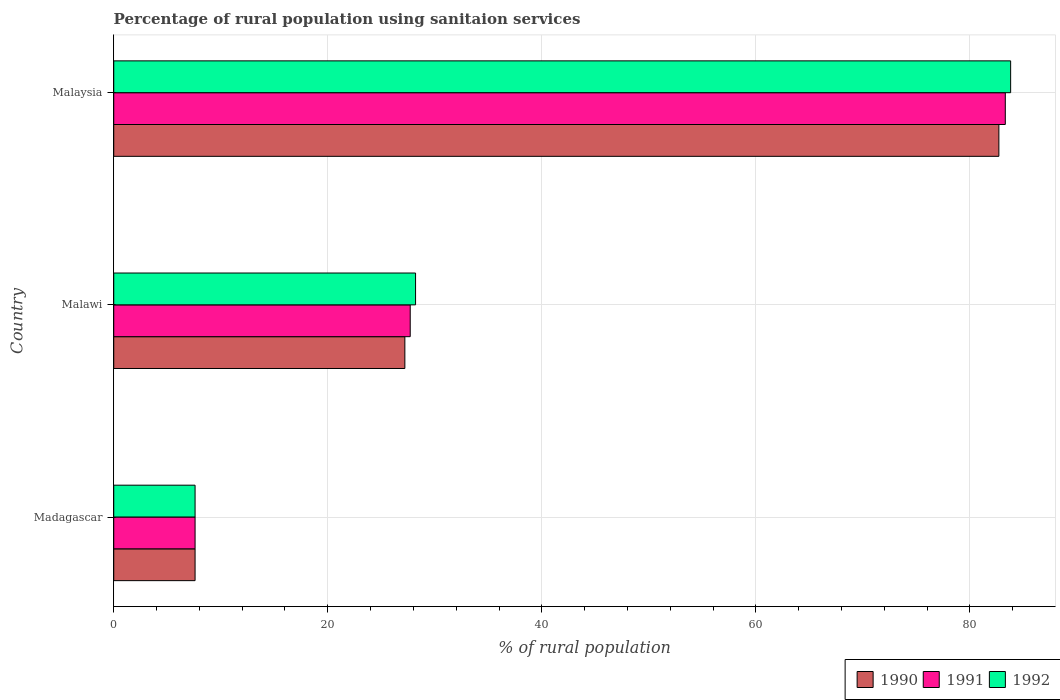How many different coloured bars are there?
Offer a terse response. 3. What is the label of the 2nd group of bars from the top?
Give a very brief answer. Malawi. Across all countries, what is the maximum percentage of rural population using sanitaion services in 1991?
Ensure brevity in your answer.  83.3. In which country was the percentage of rural population using sanitaion services in 1990 maximum?
Make the answer very short. Malaysia. In which country was the percentage of rural population using sanitaion services in 1991 minimum?
Provide a succinct answer. Madagascar. What is the total percentage of rural population using sanitaion services in 1992 in the graph?
Keep it short and to the point. 119.6. What is the difference between the percentage of rural population using sanitaion services in 1991 in Madagascar and that in Malawi?
Offer a terse response. -20.1. What is the difference between the percentage of rural population using sanitaion services in 1992 in Malawi and the percentage of rural population using sanitaion services in 1990 in Malaysia?
Your answer should be compact. -54.5. What is the average percentage of rural population using sanitaion services in 1991 per country?
Offer a terse response. 39.53. What is the difference between the percentage of rural population using sanitaion services in 1990 and percentage of rural population using sanitaion services in 1992 in Malaysia?
Offer a very short reply. -1.1. In how many countries, is the percentage of rural population using sanitaion services in 1991 greater than 16 %?
Provide a succinct answer. 2. What is the ratio of the percentage of rural population using sanitaion services in 1991 in Malawi to that in Malaysia?
Your response must be concise. 0.33. What is the difference between the highest and the second highest percentage of rural population using sanitaion services in 1991?
Provide a short and direct response. 55.6. What is the difference between the highest and the lowest percentage of rural population using sanitaion services in 1990?
Offer a very short reply. 75.1. Is the sum of the percentage of rural population using sanitaion services in 1992 in Madagascar and Malawi greater than the maximum percentage of rural population using sanitaion services in 1991 across all countries?
Give a very brief answer. No. Are all the bars in the graph horizontal?
Provide a succinct answer. Yes. Does the graph contain any zero values?
Your answer should be very brief. No. Does the graph contain grids?
Give a very brief answer. Yes. Where does the legend appear in the graph?
Keep it short and to the point. Bottom right. What is the title of the graph?
Make the answer very short. Percentage of rural population using sanitaion services. What is the label or title of the X-axis?
Provide a succinct answer. % of rural population. What is the % of rural population in 1992 in Madagascar?
Your answer should be very brief. 7.6. What is the % of rural population of 1990 in Malawi?
Offer a very short reply. 27.2. What is the % of rural population of 1991 in Malawi?
Provide a short and direct response. 27.7. What is the % of rural population of 1992 in Malawi?
Ensure brevity in your answer.  28.2. What is the % of rural population of 1990 in Malaysia?
Offer a very short reply. 82.7. What is the % of rural population in 1991 in Malaysia?
Offer a terse response. 83.3. What is the % of rural population of 1992 in Malaysia?
Give a very brief answer. 83.8. Across all countries, what is the maximum % of rural population of 1990?
Provide a succinct answer. 82.7. Across all countries, what is the maximum % of rural population in 1991?
Make the answer very short. 83.3. Across all countries, what is the maximum % of rural population of 1992?
Offer a terse response. 83.8. What is the total % of rural population in 1990 in the graph?
Make the answer very short. 117.5. What is the total % of rural population in 1991 in the graph?
Keep it short and to the point. 118.6. What is the total % of rural population of 1992 in the graph?
Give a very brief answer. 119.6. What is the difference between the % of rural population of 1990 in Madagascar and that in Malawi?
Give a very brief answer. -19.6. What is the difference between the % of rural population in 1991 in Madagascar and that in Malawi?
Your answer should be very brief. -20.1. What is the difference between the % of rural population of 1992 in Madagascar and that in Malawi?
Your response must be concise. -20.6. What is the difference between the % of rural population of 1990 in Madagascar and that in Malaysia?
Give a very brief answer. -75.1. What is the difference between the % of rural population of 1991 in Madagascar and that in Malaysia?
Your response must be concise. -75.7. What is the difference between the % of rural population in 1992 in Madagascar and that in Malaysia?
Make the answer very short. -76.2. What is the difference between the % of rural population in 1990 in Malawi and that in Malaysia?
Provide a short and direct response. -55.5. What is the difference between the % of rural population of 1991 in Malawi and that in Malaysia?
Your response must be concise. -55.6. What is the difference between the % of rural population in 1992 in Malawi and that in Malaysia?
Your answer should be compact. -55.6. What is the difference between the % of rural population in 1990 in Madagascar and the % of rural population in 1991 in Malawi?
Provide a short and direct response. -20.1. What is the difference between the % of rural population in 1990 in Madagascar and the % of rural population in 1992 in Malawi?
Give a very brief answer. -20.6. What is the difference between the % of rural population of 1991 in Madagascar and the % of rural population of 1992 in Malawi?
Offer a terse response. -20.6. What is the difference between the % of rural population of 1990 in Madagascar and the % of rural population of 1991 in Malaysia?
Your answer should be very brief. -75.7. What is the difference between the % of rural population in 1990 in Madagascar and the % of rural population in 1992 in Malaysia?
Offer a terse response. -76.2. What is the difference between the % of rural population in 1991 in Madagascar and the % of rural population in 1992 in Malaysia?
Keep it short and to the point. -76.2. What is the difference between the % of rural population in 1990 in Malawi and the % of rural population in 1991 in Malaysia?
Offer a very short reply. -56.1. What is the difference between the % of rural population of 1990 in Malawi and the % of rural population of 1992 in Malaysia?
Offer a terse response. -56.6. What is the difference between the % of rural population in 1991 in Malawi and the % of rural population in 1992 in Malaysia?
Make the answer very short. -56.1. What is the average % of rural population of 1990 per country?
Provide a short and direct response. 39.17. What is the average % of rural population of 1991 per country?
Your answer should be compact. 39.53. What is the average % of rural population in 1992 per country?
Make the answer very short. 39.87. What is the difference between the % of rural population in 1990 and % of rural population in 1991 in Madagascar?
Provide a succinct answer. 0. What is the difference between the % of rural population of 1990 and % of rural population of 1992 in Madagascar?
Make the answer very short. 0. What is the difference between the % of rural population in 1991 and % of rural population in 1992 in Madagascar?
Ensure brevity in your answer.  0. What is the difference between the % of rural population of 1991 and % of rural population of 1992 in Malawi?
Provide a short and direct response. -0.5. What is the difference between the % of rural population of 1990 and % of rural population of 1991 in Malaysia?
Make the answer very short. -0.6. What is the difference between the % of rural population of 1990 and % of rural population of 1992 in Malaysia?
Keep it short and to the point. -1.1. What is the ratio of the % of rural population of 1990 in Madagascar to that in Malawi?
Your answer should be compact. 0.28. What is the ratio of the % of rural population of 1991 in Madagascar to that in Malawi?
Your answer should be very brief. 0.27. What is the ratio of the % of rural population in 1992 in Madagascar to that in Malawi?
Provide a succinct answer. 0.27. What is the ratio of the % of rural population in 1990 in Madagascar to that in Malaysia?
Offer a very short reply. 0.09. What is the ratio of the % of rural population in 1991 in Madagascar to that in Malaysia?
Provide a succinct answer. 0.09. What is the ratio of the % of rural population in 1992 in Madagascar to that in Malaysia?
Ensure brevity in your answer.  0.09. What is the ratio of the % of rural population in 1990 in Malawi to that in Malaysia?
Make the answer very short. 0.33. What is the ratio of the % of rural population of 1991 in Malawi to that in Malaysia?
Provide a short and direct response. 0.33. What is the ratio of the % of rural population of 1992 in Malawi to that in Malaysia?
Make the answer very short. 0.34. What is the difference between the highest and the second highest % of rural population of 1990?
Your response must be concise. 55.5. What is the difference between the highest and the second highest % of rural population in 1991?
Your answer should be very brief. 55.6. What is the difference between the highest and the second highest % of rural population in 1992?
Ensure brevity in your answer.  55.6. What is the difference between the highest and the lowest % of rural population in 1990?
Give a very brief answer. 75.1. What is the difference between the highest and the lowest % of rural population of 1991?
Ensure brevity in your answer.  75.7. What is the difference between the highest and the lowest % of rural population in 1992?
Keep it short and to the point. 76.2. 